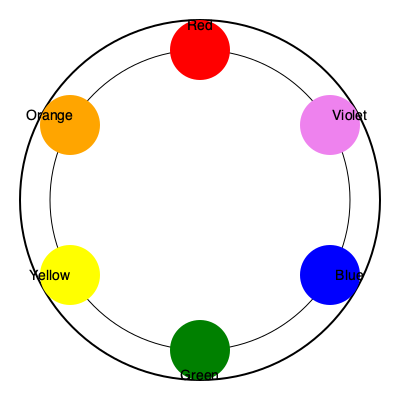As a branding expert, you understand the importance of color theory in design. Looking at the color wheel provided, which color is complementary to orange, and how might this knowledge be applied in creating a visually striking logo for a client? To answer this question, let's follow these steps:

1. Understand complementary colors:
   - Complementary colors are pairs of colors that are opposite each other on the color wheel.
   - They create high contrast and visual impact when used together.

2. Locate orange on the color wheel:
   - Orange is a secondary color, positioned between red and yellow.

3. Find the color opposite to orange:
   - The color directly across from orange on the color wheel is blue.

4. Confirm the complementary relationship:
   - Orange and blue are indeed complementary colors.

5. Application in logo design:
   - Using complementary colors in a logo can create a bold, eye-catching design.
   - The high contrast between orange and blue can make elements stand out.
   - This color combination can evoke feelings of energy, enthusiasm (orange) balanced with trust and stability (blue).
   - In a logo, you might use orange as the primary color with blue accents, or vice versa.
   - This combination works well for brands wanting to appear vibrant and reliable simultaneously.

6. Considerations for implementation:
   - While complementary colors create impact, it's important to balance them carefully to avoid overwhelming the viewer.
   - Using different shades or tints of orange and blue can provide variety while maintaining the complementary relationship.
   - Consider the client's industry and target audience when deciding how boldly to apply this color scheme.

By understanding and applying the principle of complementary colors, you can create logos and brand identities that are visually striking and memorable.
Answer: Blue; creates high contrast and visual impact in logo design. 